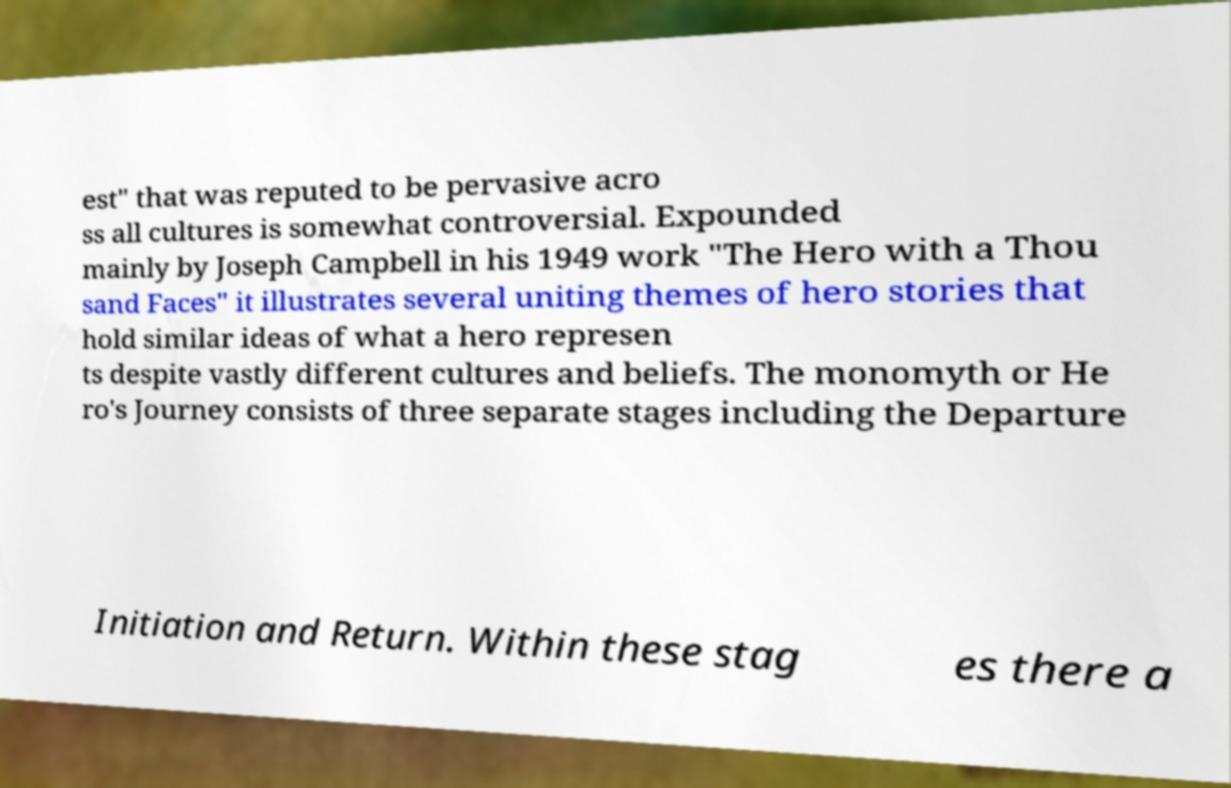I need the written content from this picture converted into text. Can you do that? est" that was reputed to be pervasive acro ss all cultures is somewhat controversial. Expounded mainly by Joseph Campbell in his 1949 work "The Hero with a Thou sand Faces" it illustrates several uniting themes of hero stories that hold similar ideas of what a hero represen ts despite vastly different cultures and beliefs. The monomyth or He ro's Journey consists of three separate stages including the Departure Initiation and Return. Within these stag es there a 